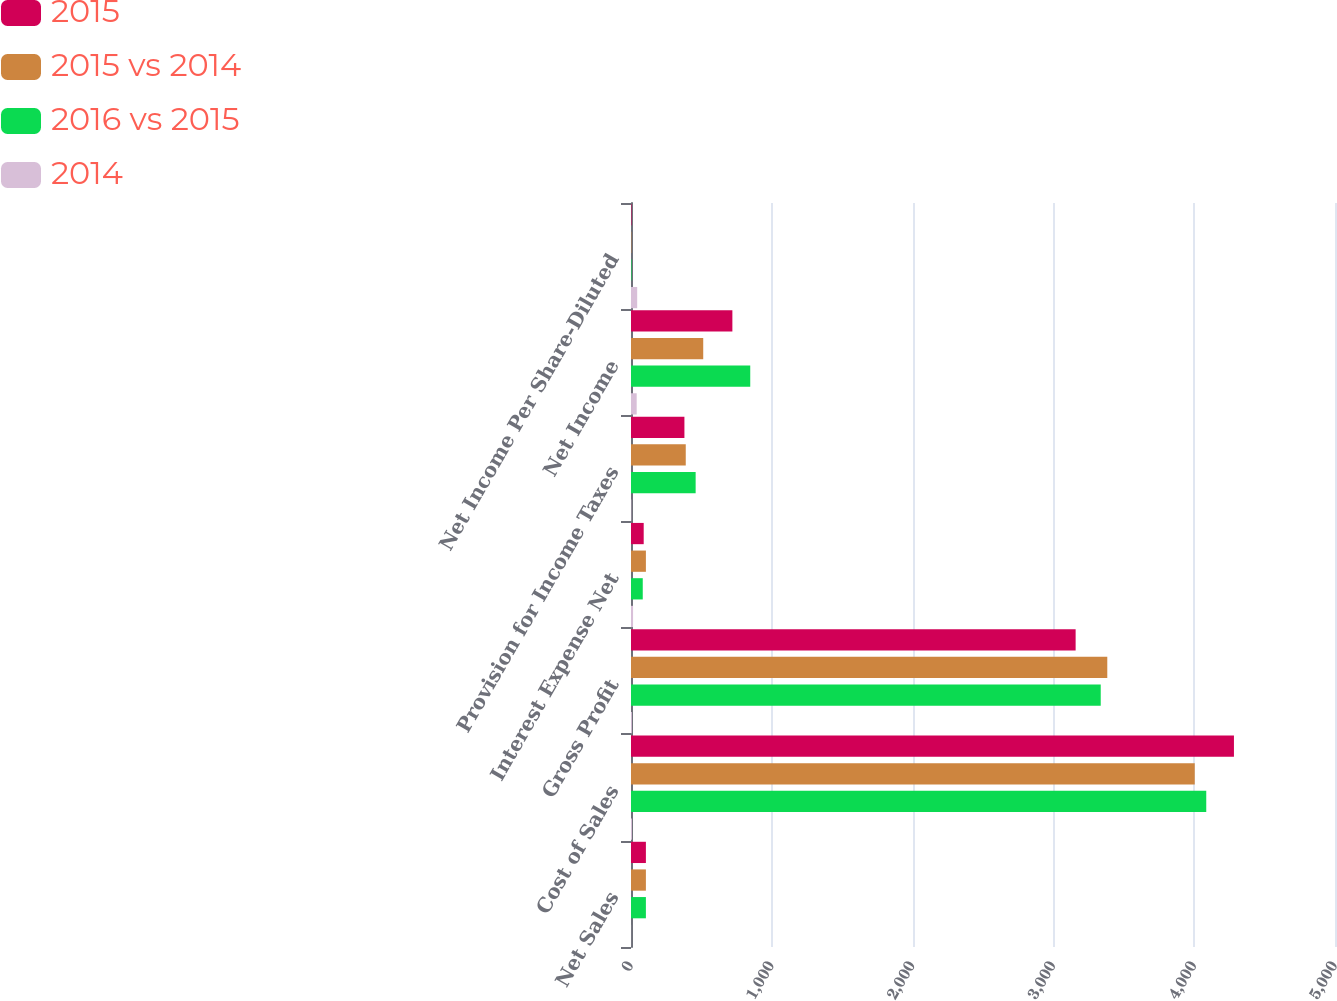Convert chart to OTSL. <chart><loc_0><loc_0><loc_500><loc_500><stacked_bar_chart><ecel><fcel>Net Sales<fcel>Cost of Sales<fcel>Gross Profit<fcel>Interest Expense Net<fcel>Provision for Income Taxes<fcel>Net Income<fcel>Net Income Per Share-Diluted<nl><fcel>2015<fcel>105.8<fcel>4282.3<fcel>3157.9<fcel>90.2<fcel>379.4<fcel>720<fcel>3.34<nl><fcel>2015 vs 2014<fcel>105.8<fcel>4003.9<fcel>3382.7<fcel>105.8<fcel>388.9<fcel>513<fcel>2.32<nl><fcel>2016 vs 2015<fcel>105.8<fcel>4085.6<fcel>3336.2<fcel>83.5<fcel>459.1<fcel>846.9<fcel>3.77<nl><fcel>2014<fcel>0.7<fcel>7<fcel>6.6<fcel>14.7<fcel>2.4<fcel>40.4<fcel>44<nl></chart> 